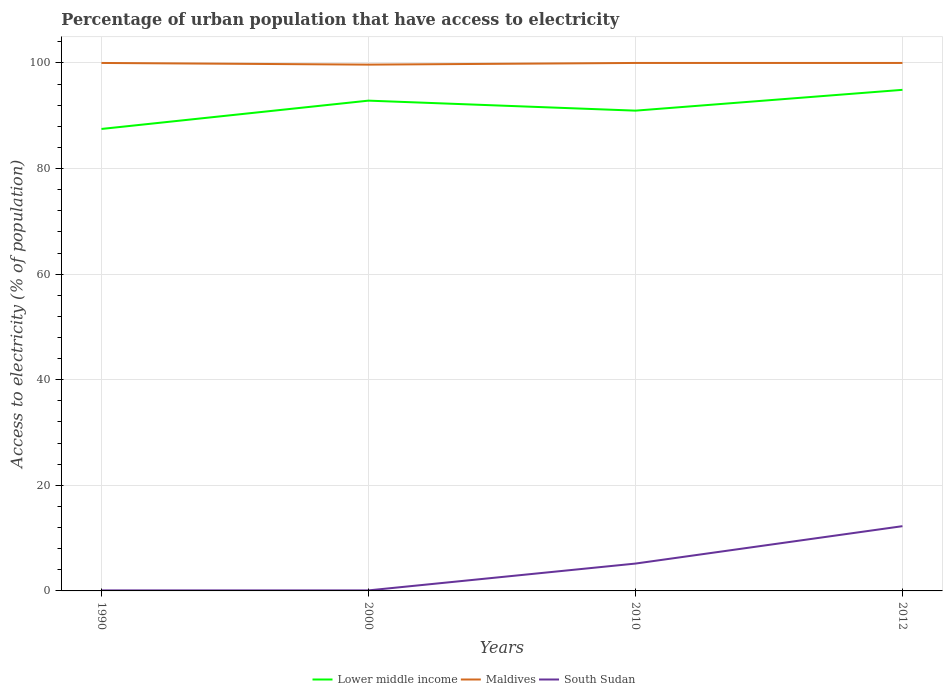Does the line corresponding to South Sudan intersect with the line corresponding to Lower middle income?
Your answer should be very brief. No. Across all years, what is the maximum percentage of urban population that have access to electricity in South Sudan?
Offer a terse response. 0.1. What is the total percentage of urban population that have access to electricity in Lower middle income in the graph?
Provide a short and direct response. -5.36. What is the difference between the highest and the second highest percentage of urban population that have access to electricity in Lower middle income?
Offer a very short reply. 7.41. What is the difference between two consecutive major ticks on the Y-axis?
Provide a succinct answer. 20. Does the graph contain any zero values?
Offer a very short reply. No. How many legend labels are there?
Keep it short and to the point. 3. What is the title of the graph?
Your response must be concise. Percentage of urban population that have access to electricity. Does "Congo (Republic)" appear as one of the legend labels in the graph?
Keep it short and to the point. No. What is the label or title of the Y-axis?
Offer a terse response. Access to electricity (% of population). What is the Access to electricity (% of population) of Lower middle income in 1990?
Offer a terse response. 87.5. What is the Access to electricity (% of population) in South Sudan in 1990?
Ensure brevity in your answer.  0.1. What is the Access to electricity (% of population) of Lower middle income in 2000?
Provide a succinct answer. 92.86. What is the Access to electricity (% of population) in Maldives in 2000?
Keep it short and to the point. 99.68. What is the Access to electricity (% of population) of Lower middle income in 2010?
Make the answer very short. 90.97. What is the Access to electricity (% of population) in South Sudan in 2010?
Your response must be concise. 5.18. What is the Access to electricity (% of population) of Lower middle income in 2012?
Give a very brief answer. 94.91. What is the Access to electricity (% of population) of Maldives in 2012?
Make the answer very short. 100. What is the Access to electricity (% of population) in South Sudan in 2012?
Provide a short and direct response. 12.27. Across all years, what is the maximum Access to electricity (% of population) in Lower middle income?
Keep it short and to the point. 94.91. Across all years, what is the maximum Access to electricity (% of population) in Maldives?
Make the answer very short. 100. Across all years, what is the maximum Access to electricity (% of population) in South Sudan?
Give a very brief answer. 12.27. Across all years, what is the minimum Access to electricity (% of population) in Lower middle income?
Make the answer very short. 87.5. Across all years, what is the minimum Access to electricity (% of population) in Maldives?
Give a very brief answer. 99.68. What is the total Access to electricity (% of population) in Lower middle income in the graph?
Give a very brief answer. 366.23. What is the total Access to electricity (% of population) of Maldives in the graph?
Your response must be concise. 399.68. What is the total Access to electricity (% of population) in South Sudan in the graph?
Make the answer very short. 17.64. What is the difference between the Access to electricity (% of population) in Lower middle income in 1990 and that in 2000?
Ensure brevity in your answer.  -5.36. What is the difference between the Access to electricity (% of population) in Maldives in 1990 and that in 2000?
Keep it short and to the point. 0.32. What is the difference between the Access to electricity (% of population) of Lower middle income in 1990 and that in 2010?
Your answer should be compact. -3.47. What is the difference between the Access to electricity (% of population) of Maldives in 1990 and that in 2010?
Provide a succinct answer. 0. What is the difference between the Access to electricity (% of population) of South Sudan in 1990 and that in 2010?
Ensure brevity in your answer.  -5.08. What is the difference between the Access to electricity (% of population) in Lower middle income in 1990 and that in 2012?
Your answer should be compact. -7.41. What is the difference between the Access to electricity (% of population) in Maldives in 1990 and that in 2012?
Provide a short and direct response. 0. What is the difference between the Access to electricity (% of population) of South Sudan in 1990 and that in 2012?
Ensure brevity in your answer.  -12.17. What is the difference between the Access to electricity (% of population) of Lower middle income in 2000 and that in 2010?
Ensure brevity in your answer.  1.9. What is the difference between the Access to electricity (% of population) in Maldives in 2000 and that in 2010?
Make the answer very short. -0.32. What is the difference between the Access to electricity (% of population) in South Sudan in 2000 and that in 2010?
Offer a terse response. -5.08. What is the difference between the Access to electricity (% of population) in Lower middle income in 2000 and that in 2012?
Your answer should be compact. -2.05. What is the difference between the Access to electricity (% of population) of Maldives in 2000 and that in 2012?
Offer a terse response. -0.32. What is the difference between the Access to electricity (% of population) of South Sudan in 2000 and that in 2012?
Your response must be concise. -12.17. What is the difference between the Access to electricity (% of population) of Lower middle income in 2010 and that in 2012?
Keep it short and to the point. -3.94. What is the difference between the Access to electricity (% of population) in South Sudan in 2010 and that in 2012?
Your answer should be compact. -7.09. What is the difference between the Access to electricity (% of population) in Lower middle income in 1990 and the Access to electricity (% of population) in Maldives in 2000?
Ensure brevity in your answer.  -12.19. What is the difference between the Access to electricity (% of population) of Lower middle income in 1990 and the Access to electricity (% of population) of South Sudan in 2000?
Provide a short and direct response. 87.4. What is the difference between the Access to electricity (% of population) in Maldives in 1990 and the Access to electricity (% of population) in South Sudan in 2000?
Make the answer very short. 99.9. What is the difference between the Access to electricity (% of population) of Lower middle income in 1990 and the Access to electricity (% of population) of Maldives in 2010?
Keep it short and to the point. -12.5. What is the difference between the Access to electricity (% of population) in Lower middle income in 1990 and the Access to electricity (% of population) in South Sudan in 2010?
Offer a terse response. 82.32. What is the difference between the Access to electricity (% of population) in Maldives in 1990 and the Access to electricity (% of population) in South Sudan in 2010?
Offer a terse response. 94.82. What is the difference between the Access to electricity (% of population) of Lower middle income in 1990 and the Access to electricity (% of population) of Maldives in 2012?
Give a very brief answer. -12.5. What is the difference between the Access to electricity (% of population) in Lower middle income in 1990 and the Access to electricity (% of population) in South Sudan in 2012?
Give a very brief answer. 75.23. What is the difference between the Access to electricity (% of population) in Maldives in 1990 and the Access to electricity (% of population) in South Sudan in 2012?
Give a very brief answer. 87.73. What is the difference between the Access to electricity (% of population) of Lower middle income in 2000 and the Access to electricity (% of population) of Maldives in 2010?
Your response must be concise. -7.14. What is the difference between the Access to electricity (% of population) in Lower middle income in 2000 and the Access to electricity (% of population) in South Sudan in 2010?
Keep it short and to the point. 87.68. What is the difference between the Access to electricity (% of population) in Maldives in 2000 and the Access to electricity (% of population) in South Sudan in 2010?
Provide a short and direct response. 94.5. What is the difference between the Access to electricity (% of population) of Lower middle income in 2000 and the Access to electricity (% of population) of Maldives in 2012?
Offer a terse response. -7.14. What is the difference between the Access to electricity (% of population) of Lower middle income in 2000 and the Access to electricity (% of population) of South Sudan in 2012?
Keep it short and to the point. 80.6. What is the difference between the Access to electricity (% of population) of Maldives in 2000 and the Access to electricity (% of population) of South Sudan in 2012?
Offer a very short reply. 87.42. What is the difference between the Access to electricity (% of population) in Lower middle income in 2010 and the Access to electricity (% of population) in Maldives in 2012?
Give a very brief answer. -9.03. What is the difference between the Access to electricity (% of population) of Lower middle income in 2010 and the Access to electricity (% of population) of South Sudan in 2012?
Make the answer very short. 78.7. What is the difference between the Access to electricity (% of population) of Maldives in 2010 and the Access to electricity (% of population) of South Sudan in 2012?
Your answer should be very brief. 87.73. What is the average Access to electricity (% of population) of Lower middle income per year?
Offer a terse response. 91.56. What is the average Access to electricity (% of population) of Maldives per year?
Your answer should be very brief. 99.92. What is the average Access to electricity (% of population) in South Sudan per year?
Your answer should be compact. 4.41. In the year 1990, what is the difference between the Access to electricity (% of population) in Lower middle income and Access to electricity (% of population) in Maldives?
Offer a terse response. -12.5. In the year 1990, what is the difference between the Access to electricity (% of population) in Lower middle income and Access to electricity (% of population) in South Sudan?
Offer a very short reply. 87.4. In the year 1990, what is the difference between the Access to electricity (% of population) of Maldives and Access to electricity (% of population) of South Sudan?
Give a very brief answer. 99.9. In the year 2000, what is the difference between the Access to electricity (% of population) of Lower middle income and Access to electricity (% of population) of Maldives?
Make the answer very short. -6.82. In the year 2000, what is the difference between the Access to electricity (% of population) of Lower middle income and Access to electricity (% of population) of South Sudan?
Give a very brief answer. 92.76. In the year 2000, what is the difference between the Access to electricity (% of population) in Maldives and Access to electricity (% of population) in South Sudan?
Provide a succinct answer. 99.58. In the year 2010, what is the difference between the Access to electricity (% of population) in Lower middle income and Access to electricity (% of population) in Maldives?
Offer a terse response. -9.03. In the year 2010, what is the difference between the Access to electricity (% of population) of Lower middle income and Access to electricity (% of population) of South Sudan?
Provide a short and direct response. 85.79. In the year 2010, what is the difference between the Access to electricity (% of population) in Maldives and Access to electricity (% of population) in South Sudan?
Provide a succinct answer. 94.82. In the year 2012, what is the difference between the Access to electricity (% of population) of Lower middle income and Access to electricity (% of population) of Maldives?
Give a very brief answer. -5.09. In the year 2012, what is the difference between the Access to electricity (% of population) in Lower middle income and Access to electricity (% of population) in South Sudan?
Keep it short and to the point. 82.64. In the year 2012, what is the difference between the Access to electricity (% of population) of Maldives and Access to electricity (% of population) of South Sudan?
Your answer should be compact. 87.73. What is the ratio of the Access to electricity (% of population) in Lower middle income in 1990 to that in 2000?
Your answer should be compact. 0.94. What is the ratio of the Access to electricity (% of population) in Maldives in 1990 to that in 2000?
Your answer should be compact. 1. What is the ratio of the Access to electricity (% of population) of Lower middle income in 1990 to that in 2010?
Your answer should be very brief. 0.96. What is the ratio of the Access to electricity (% of population) of Maldives in 1990 to that in 2010?
Provide a short and direct response. 1. What is the ratio of the Access to electricity (% of population) in South Sudan in 1990 to that in 2010?
Your answer should be compact. 0.02. What is the ratio of the Access to electricity (% of population) of Lower middle income in 1990 to that in 2012?
Keep it short and to the point. 0.92. What is the ratio of the Access to electricity (% of population) of Maldives in 1990 to that in 2012?
Provide a short and direct response. 1. What is the ratio of the Access to electricity (% of population) in South Sudan in 1990 to that in 2012?
Ensure brevity in your answer.  0.01. What is the ratio of the Access to electricity (% of population) of Lower middle income in 2000 to that in 2010?
Provide a succinct answer. 1.02. What is the ratio of the Access to electricity (% of population) in South Sudan in 2000 to that in 2010?
Your answer should be very brief. 0.02. What is the ratio of the Access to electricity (% of population) in Lower middle income in 2000 to that in 2012?
Keep it short and to the point. 0.98. What is the ratio of the Access to electricity (% of population) in Maldives in 2000 to that in 2012?
Your answer should be compact. 1. What is the ratio of the Access to electricity (% of population) in South Sudan in 2000 to that in 2012?
Make the answer very short. 0.01. What is the ratio of the Access to electricity (% of population) of Lower middle income in 2010 to that in 2012?
Provide a short and direct response. 0.96. What is the ratio of the Access to electricity (% of population) in Maldives in 2010 to that in 2012?
Your answer should be compact. 1. What is the ratio of the Access to electricity (% of population) of South Sudan in 2010 to that in 2012?
Make the answer very short. 0.42. What is the difference between the highest and the second highest Access to electricity (% of population) in Lower middle income?
Your answer should be compact. 2.05. What is the difference between the highest and the second highest Access to electricity (% of population) in South Sudan?
Your response must be concise. 7.09. What is the difference between the highest and the lowest Access to electricity (% of population) in Lower middle income?
Give a very brief answer. 7.41. What is the difference between the highest and the lowest Access to electricity (% of population) in Maldives?
Offer a very short reply. 0.32. What is the difference between the highest and the lowest Access to electricity (% of population) in South Sudan?
Make the answer very short. 12.17. 